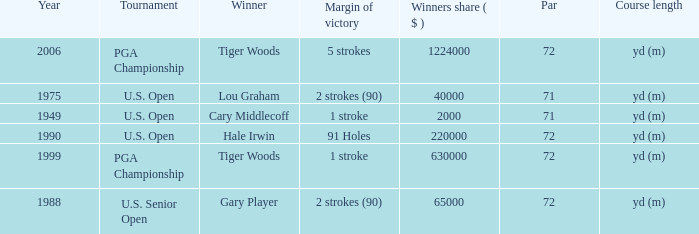When 1999 is the year how many tournaments are there? 1.0. 